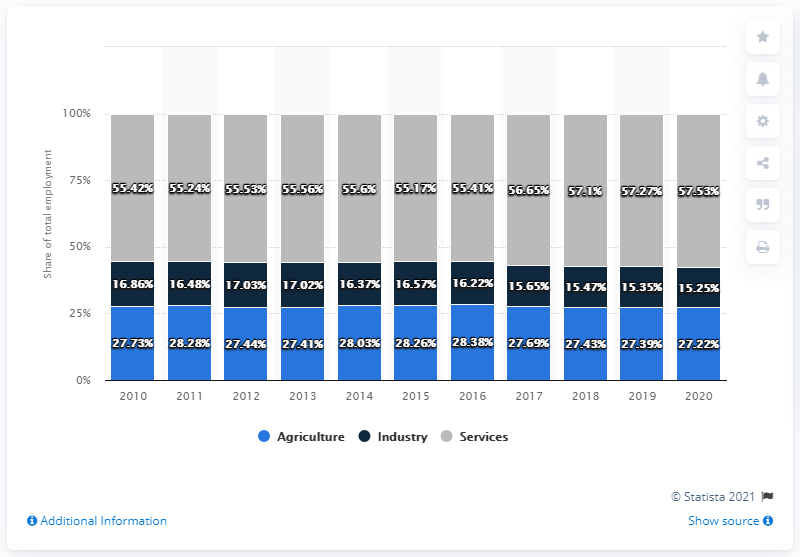Give some essential details in this illustration. The agriculture of 2020 differed significantly from that of 2019, with a difference of 0.1. In 2012, employment in the industries sector was higher than in any other year. 